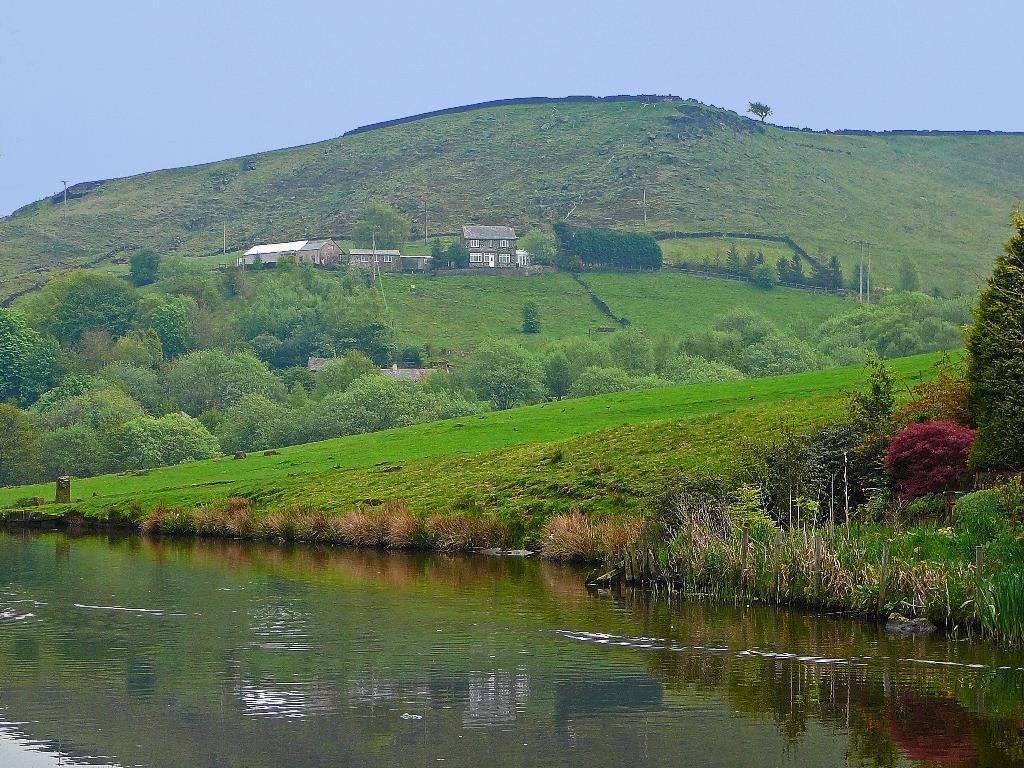Can you describe this image briefly? In this image few buildings are on the grassland having few trees. Behind there is a hill. Right side there are few plants and trees on the grassland. Bottom of the image there is water. Top of the image there is sky. 